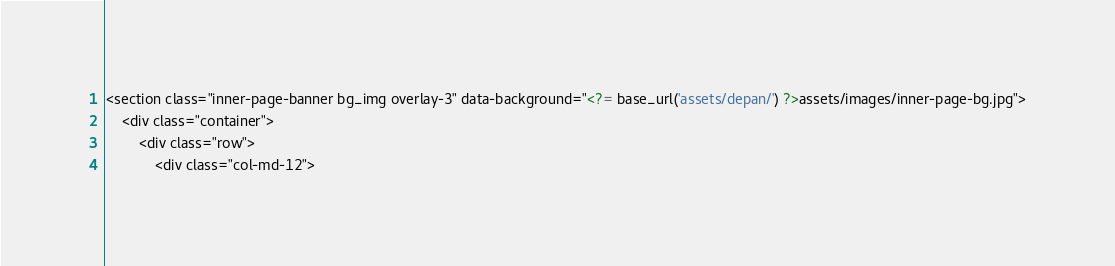<code> <loc_0><loc_0><loc_500><loc_500><_PHP_><section class="inner-page-banner bg_img overlay-3" data-background="<?= base_url('assets/depan/') ?>assets/images/inner-page-bg.jpg">
    <div class="container">
        <div class="row">
            <div class="col-md-12"></code> 